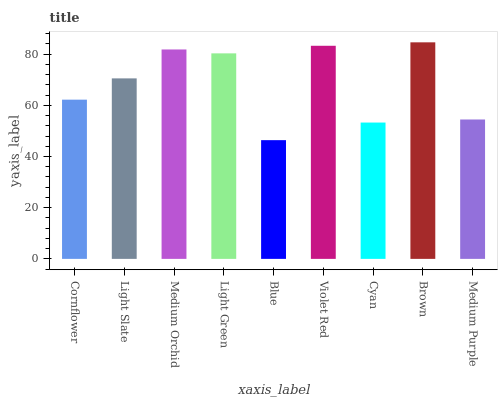Is Blue the minimum?
Answer yes or no. Yes. Is Brown the maximum?
Answer yes or no. Yes. Is Light Slate the minimum?
Answer yes or no. No. Is Light Slate the maximum?
Answer yes or no. No. Is Light Slate greater than Cornflower?
Answer yes or no. Yes. Is Cornflower less than Light Slate?
Answer yes or no. Yes. Is Cornflower greater than Light Slate?
Answer yes or no. No. Is Light Slate less than Cornflower?
Answer yes or no. No. Is Light Slate the high median?
Answer yes or no. Yes. Is Light Slate the low median?
Answer yes or no. Yes. Is Light Green the high median?
Answer yes or no. No. Is Light Green the low median?
Answer yes or no. No. 